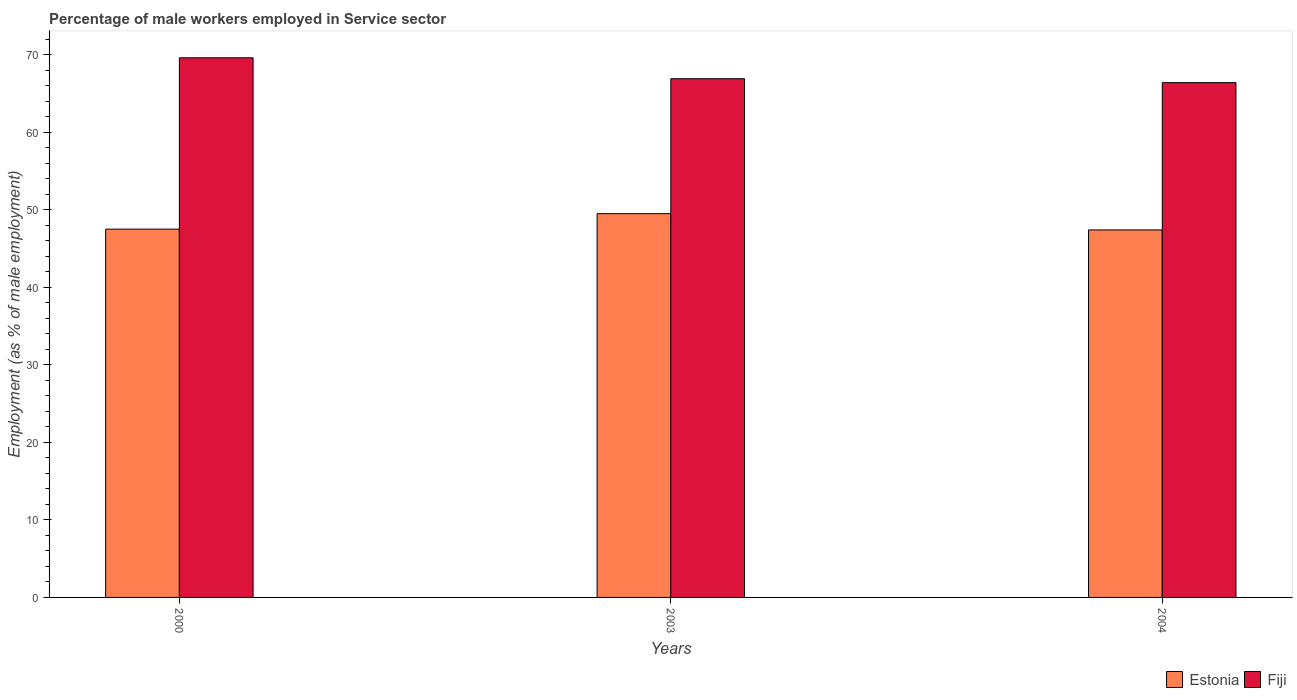How many different coloured bars are there?
Give a very brief answer. 2. How many groups of bars are there?
Offer a very short reply. 3. How many bars are there on the 1st tick from the right?
Give a very brief answer. 2. What is the label of the 1st group of bars from the left?
Give a very brief answer. 2000. What is the percentage of male workers employed in Service sector in Estonia in 2004?
Your answer should be very brief. 47.4. Across all years, what is the maximum percentage of male workers employed in Service sector in Fiji?
Ensure brevity in your answer.  69.6. Across all years, what is the minimum percentage of male workers employed in Service sector in Estonia?
Ensure brevity in your answer.  47.4. In which year was the percentage of male workers employed in Service sector in Fiji maximum?
Keep it short and to the point. 2000. In which year was the percentage of male workers employed in Service sector in Estonia minimum?
Your answer should be very brief. 2004. What is the total percentage of male workers employed in Service sector in Fiji in the graph?
Provide a succinct answer. 202.9. What is the difference between the percentage of male workers employed in Service sector in Estonia in 2000 and that in 2004?
Ensure brevity in your answer.  0.1. What is the difference between the percentage of male workers employed in Service sector in Estonia in 2000 and the percentage of male workers employed in Service sector in Fiji in 2003?
Keep it short and to the point. -19.4. What is the average percentage of male workers employed in Service sector in Fiji per year?
Give a very brief answer. 67.63. In the year 2004, what is the difference between the percentage of male workers employed in Service sector in Estonia and percentage of male workers employed in Service sector in Fiji?
Provide a short and direct response. -19. In how many years, is the percentage of male workers employed in Service sector in Fiji greater than 62 %?
Ensure brevity in your answer.  3. What is the ratio of the percentage of male workers employed in Service sector in Fiji in 2000 to that in 2003?
Ensure brevity in your answer.  1.04. What is the difference between the highest and the lowest percentage of male workers employed in Service sector in Estonia?
Make the answer very short. 2.1. In how many years, is the percentage of male workers employed in Service sector in Estonia greater than the average percentage of male workers employed in Service sector in Estonia taken over all years?
Provide a short and direct response. 1. What does the 2nd bar from the left in 2004 represents?
Give a very brief answer. Fiji. What does the 2nd bar from the right in 2000 represents?
Ensure brevity in your answer.  Estonia. Are all the bars in the graph horizontal?
Make the answer very short. No. How many years are there in the graph?
Your response must be concise. 3. What is the difference between two consecutive major ticks on the Y-axis?
Your answer should be compact. 10. How are the legend labels stacked?
Offer a very short reply. Horizontal. What is the title of the graph?
Your answer should be very brief. Percentage of male workers employed in Service sector. Does "Guinea" appear as one of the legend labels in the graph?
Provide a succinct answer. No. What is the label or title of the Y-axis?
Provide a succinct answer. Employment (as % of male employment). What is the Employment (as % of male employment) in Estonia in 2000?
Keep it short and to the point. 47.5. What is the Employment (as % of male employment) in Fiji in 2000?
Your answer should be very brief. 69.6. What is the Employment (as % of male employment) in Estonia in 2003?
Make the answer very short. 49.5. What is the Employment (as % of male employment) of Fiji in 2003?
Give a very brief answer. 66.9. What is the Employment (as % of male employment) of Estonia in 2004?
Provide a succinct answer. 47.4. What is the Employment (as % of male employment) of Fiji in 2004?
Keep it short and to the point. 66.4. Across all years, what is the maximum Employment (as % of male employment) of Estonia?
Ensure brevity in your answer.  49.5. Across all years, what is the maximum Employment (as % of male employment) of Fiji?
Offer a terse response. 69.6. Across all years, what is the minimum Employment (as % of male employment) in Estonia?
Your response must be concise. 47.4. Across all years, what is the minimum Employment (as % of male employment) of Fiji?
Make the answer very short. 66.4. What is the total Employment (as % of male employment) in Estonia in the graph?
Offer a terse response. 144.4. What is the total Employment (as % of male employment) of Fiji in the graph?
Offer a terse response. 202.9. What is the difference between the Employment (as % of male employment) of Estonia in 2000 and that in 2004?
Make the answer very short. 0.1. What is the difference between the Employment (as % of male employment) of Fiji in 2000 and that in 2004?
Give a very brief answer. 3.2. What is the difference between the Employment (as % of male employment) of Fiji in 2003 and that in 2004?
Provide a short and direct response. 0.5. What is the difference between the Employment (as % of male employment) of Estonia in 2000 and the Employment (as % of male employment) of Fiji in 2003?
Your answer should be very brief. -19.4. What is the difference between the Employment (as % of male employment) in Estonia in 2000 and the Employment (as % of male employment) in Fiji in 2004?
Offer a very short reply. -18.9. What is the difference between the Employment (as % of male employment) of Estonia in 2003 and the Employment (as % of male employment) of Fiji in 2004?
Offer a very short reply. -16.9. What is the average Employment (as % of male employment) in Estonia per year?
Your response must be concise. 48.13. What is the average Employment (as % of male employment) in Fiji per year?
Make the answer very short. 67.63. In the year 2000, what is the difference between the Employment (as % of male employment) in Estonia and Employment (as % of male employment) in Fiji?
Keep it short and to the point. -22.1. In the year 2003, what is the difference between the Employment (as % of male employment) in Estonia and Employment (as % of male employment) in Fiji?
Offer a very short reply. -17.4. In the year 2004, what is the difference between the Employment (as % of male employment) in Estonia and Employment (as % of male employment) in Fiji?
Make the answer very short. -19. What is the ratio of the Employment (as % of male employment) in Estonia in 2000 to that in 2003?
Provide a succinct answer. 0.96. What is the ratio of the Employment (as % of male employment) of Fiji in 2000 to that in 2003?
Ensure brevity in your answer.  1.04. What is the ratio of the Employment (as % of male employment) of Estonia in 2000 to that in 2004?
Offer a terse response. 1. What is the ratio of the Employment (as % of male employment) of Fiji in 2000 to that in 2004?
Provide a succinct answer. 1.05. What is the ratio of the Employment (as % of male employment) of Estonia in 2003 to that in 2004?
Provide a succinct answer. 1.04. What is the ratio of the Employment (as % of male employment) in Fiji in 2003 to that in 2004?
Keep it short and to the point. 1.01. 